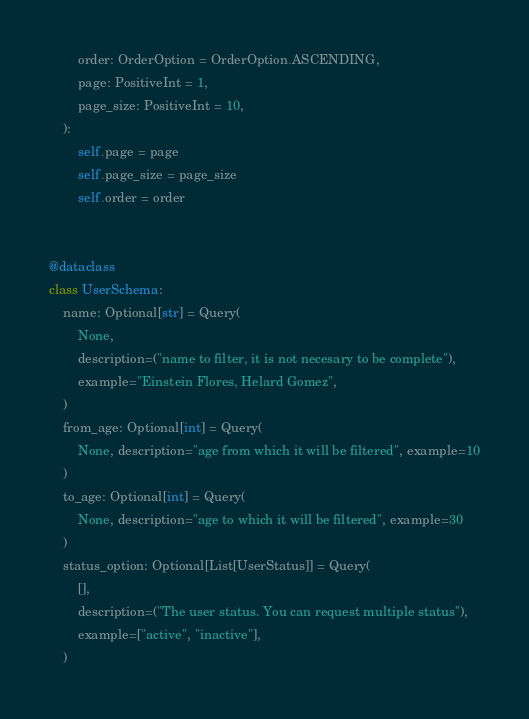<code> <loc_0><loc_0><loc_500><loc_500><_Python_>        order: OrderOption = OrderOption.ASCENDING,
        page: PositiveInt = 1,
        page_size: PositiveInt = 10,
    ):
        self.page = page
        self.page_size = page_size
        self.order = order


@dataclass
class UserSchema:
    name: Optional[str] = Query(
        None,
        description=("name to filter, it is not necesary to be complete"),
        example="Einstein Flores, Helard Gomez",
    )
    from_age: Optional[int] = Query(
        None, description="age from which it will be filtered", example=10
    )
    to_age: Optional[int] = Query(
        None, description="age to which it will be filtered", example=30
    )
    status_option: Optional[List[UserStatus]] = Query(
        [],
        description=("The user status. You can request multiple status"),
        example=["active", "inactive"],
    )
</code> 